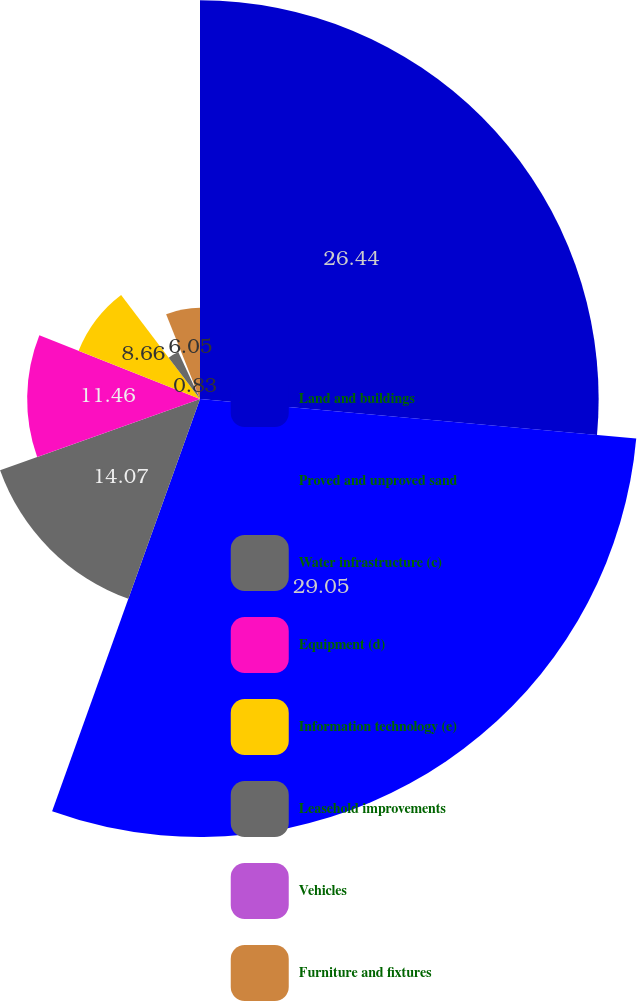Convert chart to OTSL. <chart><loc_0><loc_0><loc_500><loc_500><pie_chart><fcel>Land and buildings<fcel>Proved and unproved sand<fcel>Water infrastructure (c)<fcel>Equipment (d)<fcel>Information technology (e)<fcel>Leasehold improvements<fcel>Vehicles<fcel>Furniture and fixtures<nl><fcel>26.43%<fcel>29.04%<fcel>14.07%<fcel>11.46%<fcel>8.66%<fcel>3.44%<fcel>0.83%<fcel>6.05%<nl></chart> 